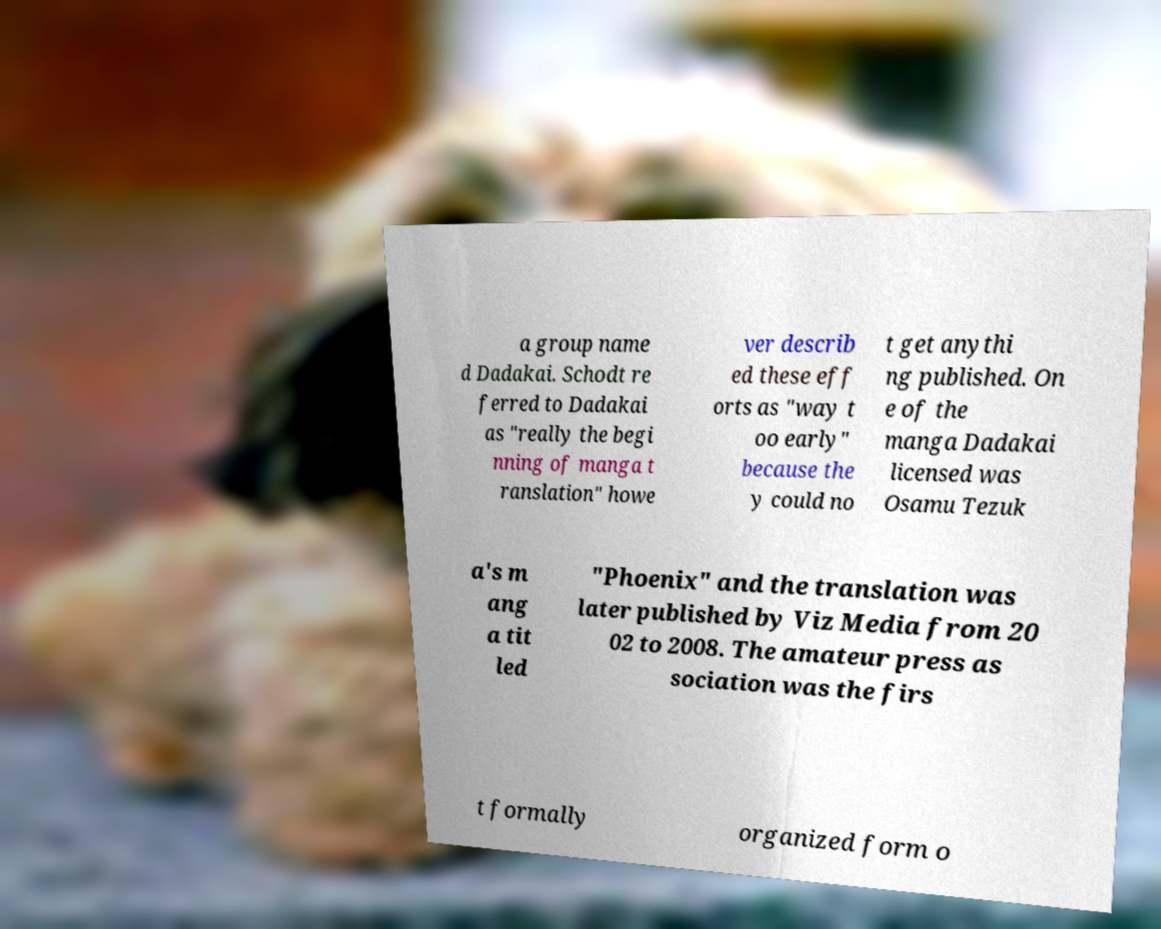Please read and relay the text visible in this image. What does it say? a group name d Dadakai. Schodt re ferred to Dadakai as "really the begi nning of manga t ranslation" howe ver describ ed these eff orts as "way t oo early" because the y could no t get anythi ng published. On e of the manga Dadakai licensed was Osamu Tezuk a's m ang a tit led "Phoenix" and the translation was later published by Viz Media from 20 02 to 2008. The amateur press as sociation was the firs t formally organized form o 